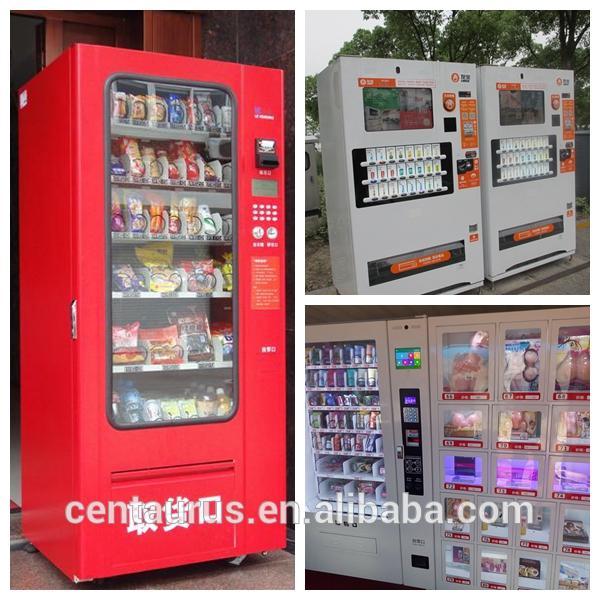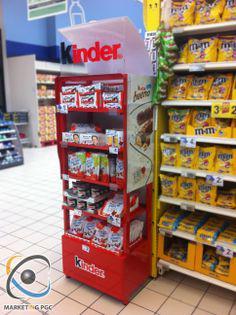The first image is the image on the left, the second image is the image on the right. Evaluate the accuracy of this statement regarding the images: "The vending machine in the left image sells eggs, and does not have visible chickens in it.". Is it true? Answer yes or no. No. The first image is the image on the left, the second image is the image on the right. Analyze the images presented: Is the assertion "There is at least one red vending machine in full view that accepts cash to dispense the food or drink." valid? Answer yes or no. Yes. 